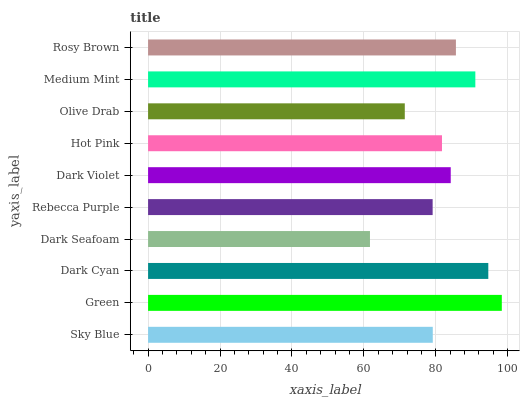Is Dark Seafoam the minimum?
Answer yes or no. Yes. Is Green the maximum?
Answer yes or no. Yes. Is Dark Cyan the minimum?
Answer yes or no. No. Is Dark Cyan the maximum?
Answer yes or no. No. Is Green greater than Dark Cyan?
Answer yes or no. Yes. Is Dark Cyan less than Green?
Answer yes or no. Yes. Is Dark Cyan greater than Green?
Answer yes or no. No. Is Green less than Dark Cyan?
Answer yes or no. No. Is Dark Violet the high median?
Answer yes or no. Yes. Is Hot Pink the low median?
Answer yes or no. Yes. Is Olive Drab the high median?
Answer yes or no. No. Is Rebecca Purple the low median?
Answer yes or no. No. 